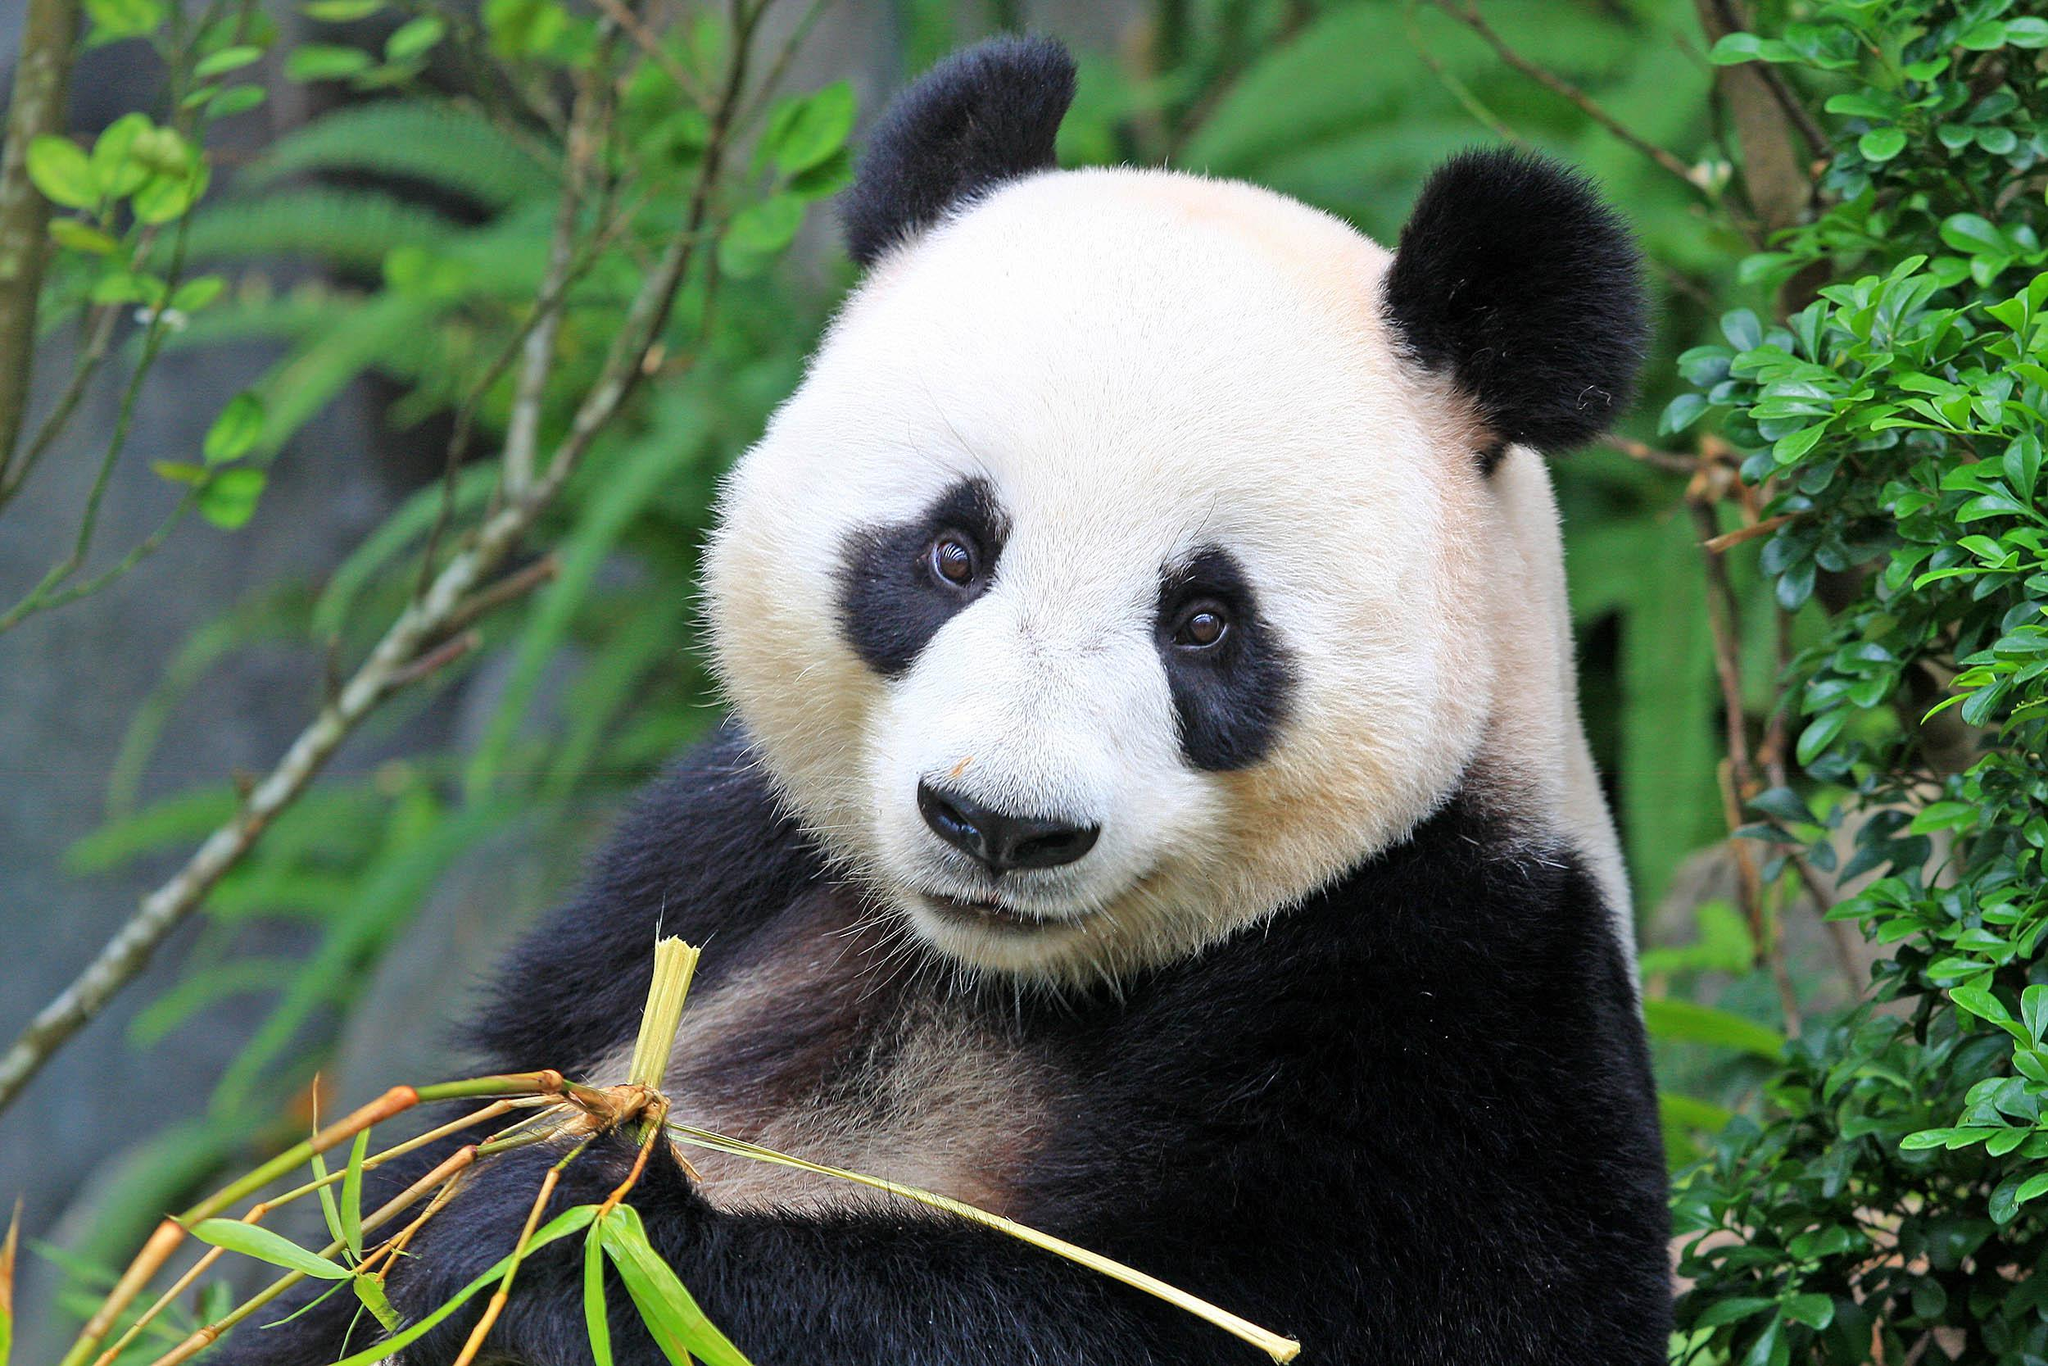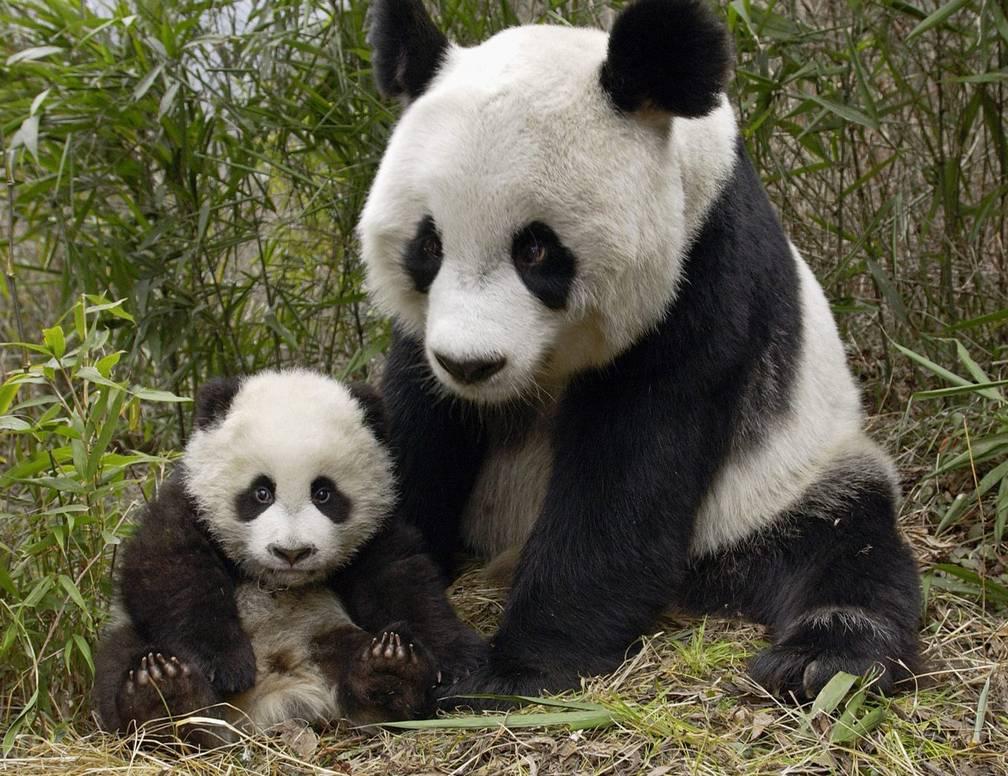The first image is the image on the left, the second image is the image on the right. Assess this claim about the two images: "There are two pandas in the image on the right.". Correct or not? Answer yes or no. Yes. 